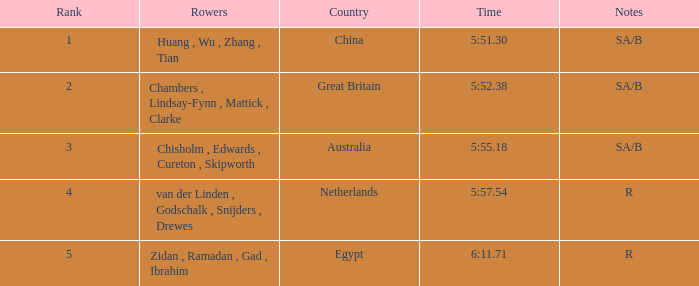What country has sa/b as the notes, and a time of 5:51.30? China. 